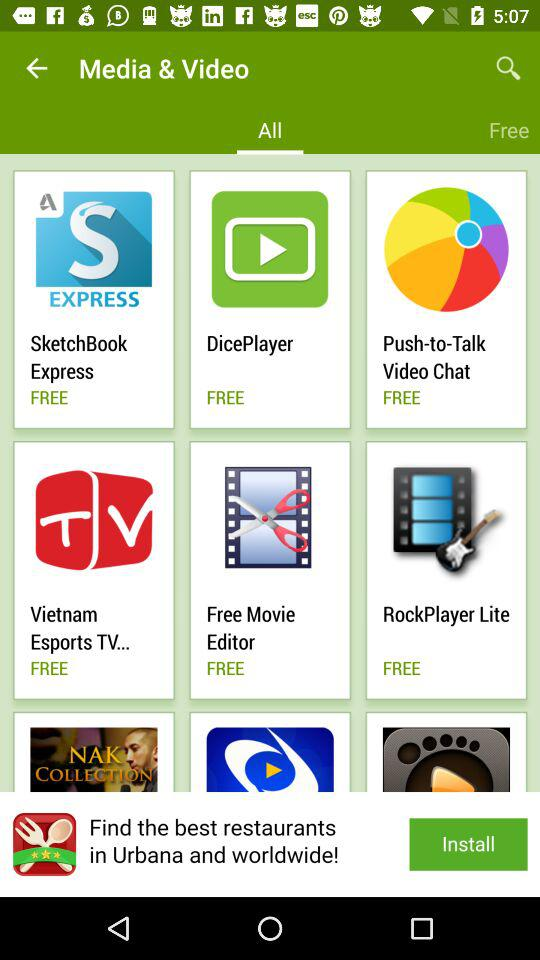What are the names of the free applications? The names of the free applications are "SketchBook Express", "DicePlayer", "Push-to-Talk Video Chat", "Vietnam Esports TV...", "Free Movie Editor" and "RockPlayer Lite". 